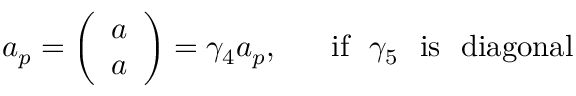<formula> <loc_0><loc_0><loc_500><loc_500>a _ { p } = \left ( \begin{array} { c } { a } \\ { a } \end{array} \right ) = \gamma _ { 4 } a _ { p } , i f \gamma _ { 5 } i s d i a g o n a l</formula> 